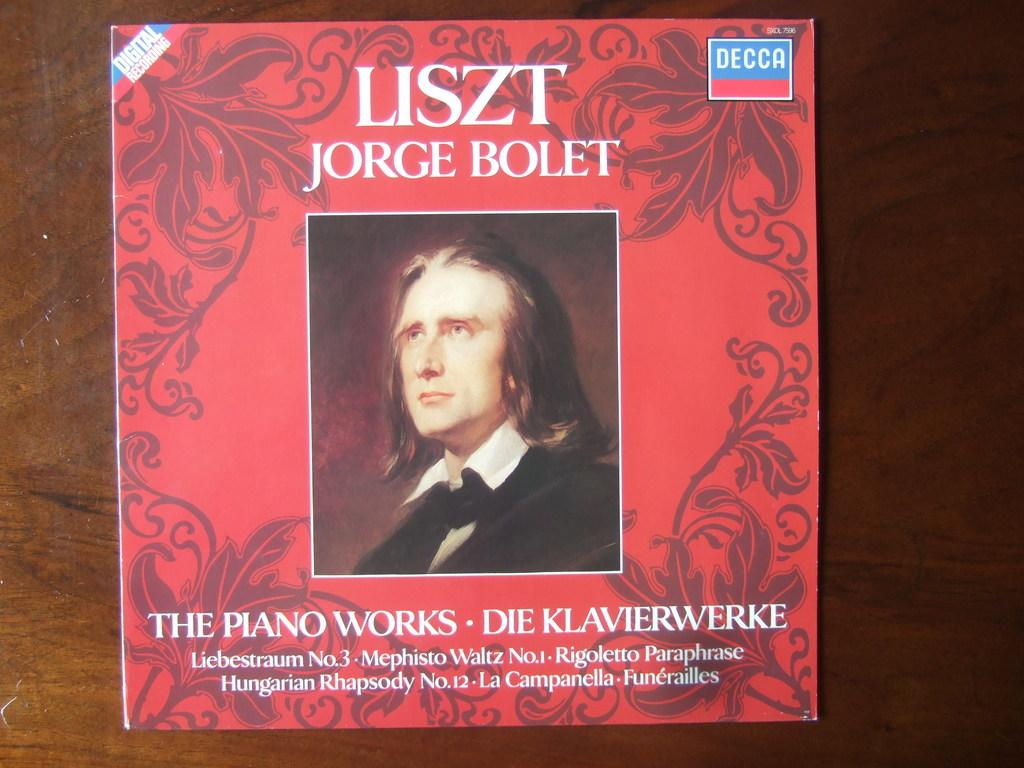What is present on a surface in the image? There is a poster on a wooden surface in the image. What can be seen on the poster? There is an image of a person on the poster. Is there any text on the poster? Yes, there is text on the poster. How many frogs are sitting on the airport in the image? There are no frogs or airports present in the image. What advice does the grandfather give on the poster? There is no grandfather or advice present on the poster; it features an image of a person and text. 